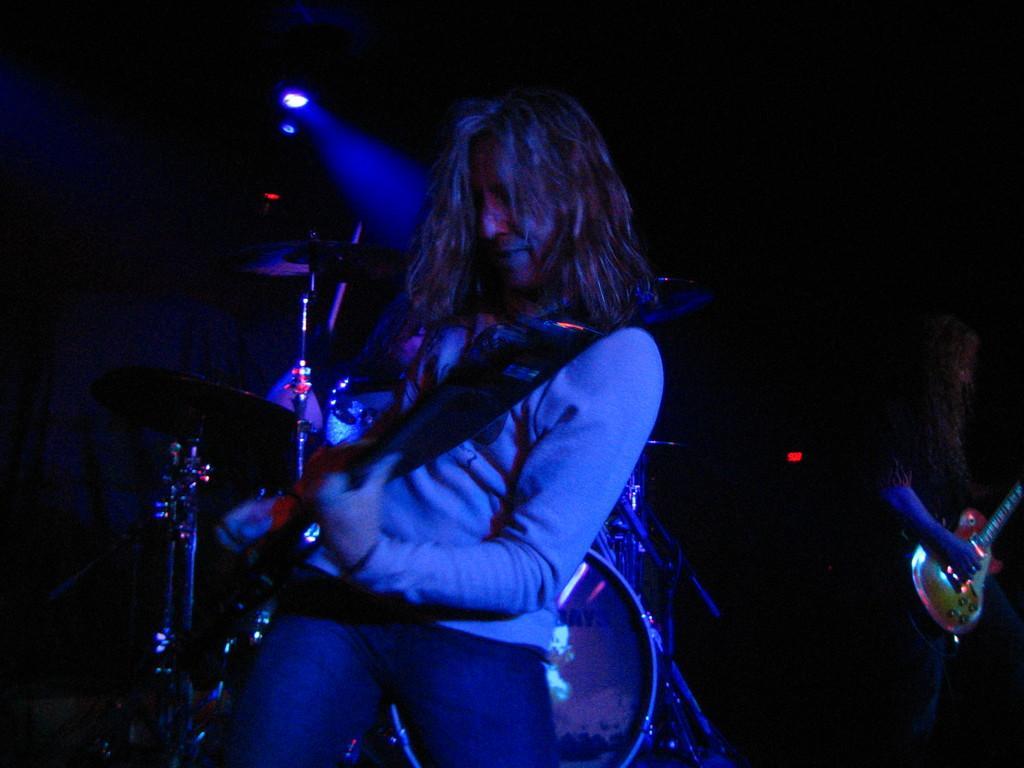How would you summarize this image in a sentence or two? A person is playing the guitar, this person wore sweater and trouser, in the middle there are focused lights. 